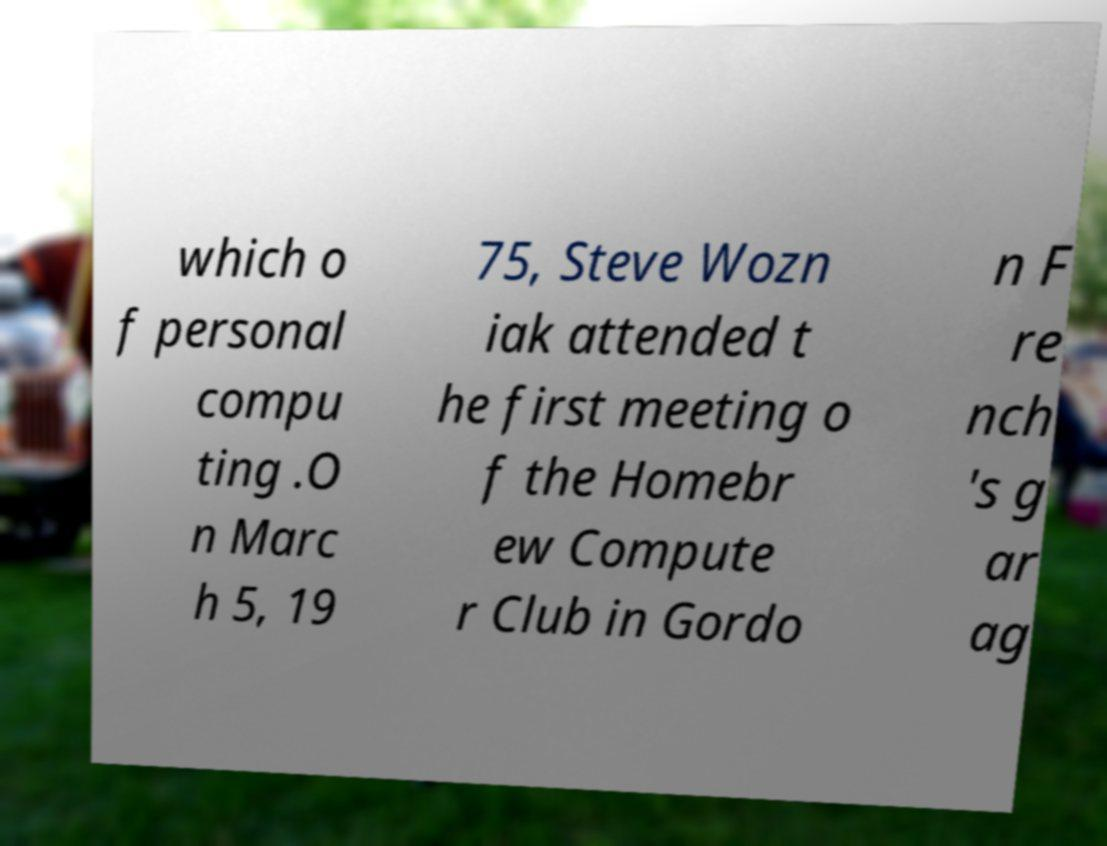Can you read and provide the text displayed in the image?This photo seems to have some interesting text. Can you extract and type it out for me? which o f personal compu ting .O n Marc h 5, 19 75, Steve Wozn iak attended t he first meeting o f the Homebr ew Compute r Club in Gordo n F re nch 's g ar ag 